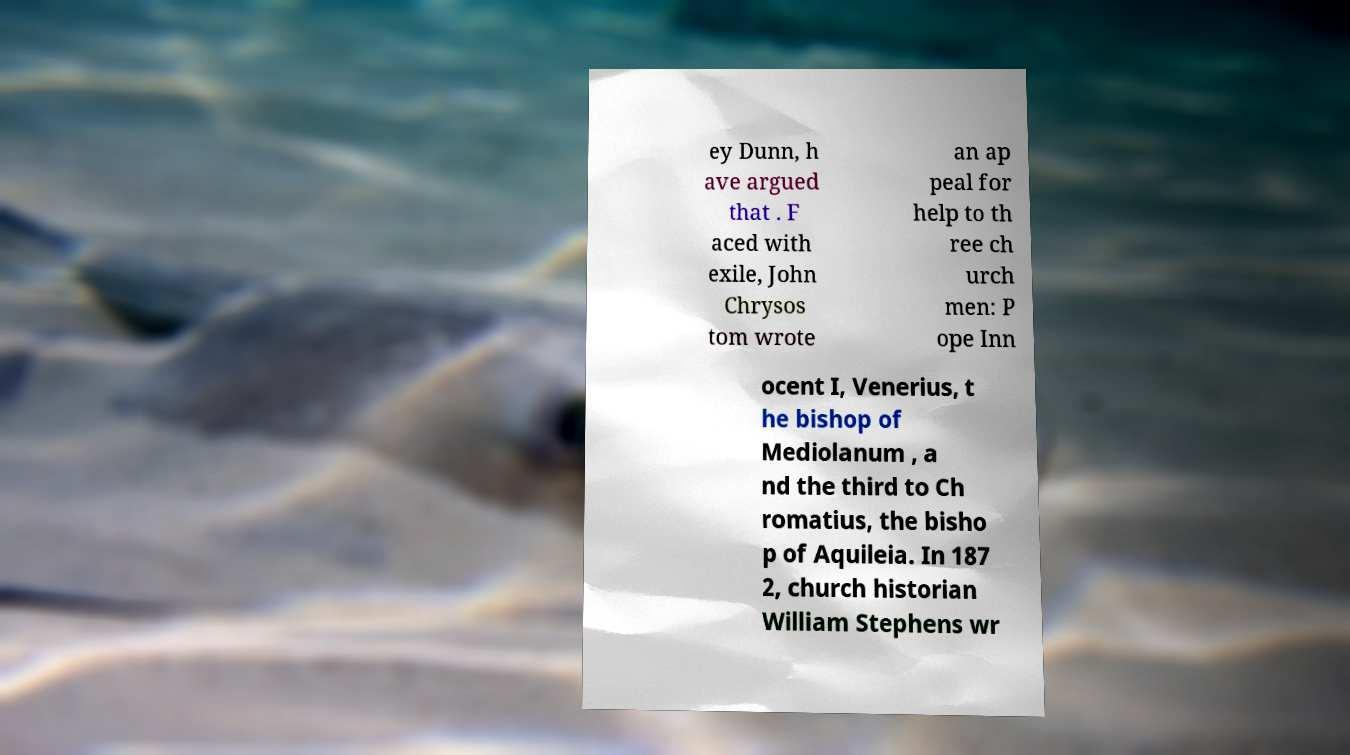Could you extract and type out the text from this image? ey Dunn, h ave argued that . F aced with exile, John Chrysos tom wrote an ap peal for help to th ree ch urch men: P ope Inn ocent I, Venerius, t he bishop of Mediolanum , a nd the third to Ch romatius, the bisho p of Aquileia. In 187 2, church historian William Stephens wr 